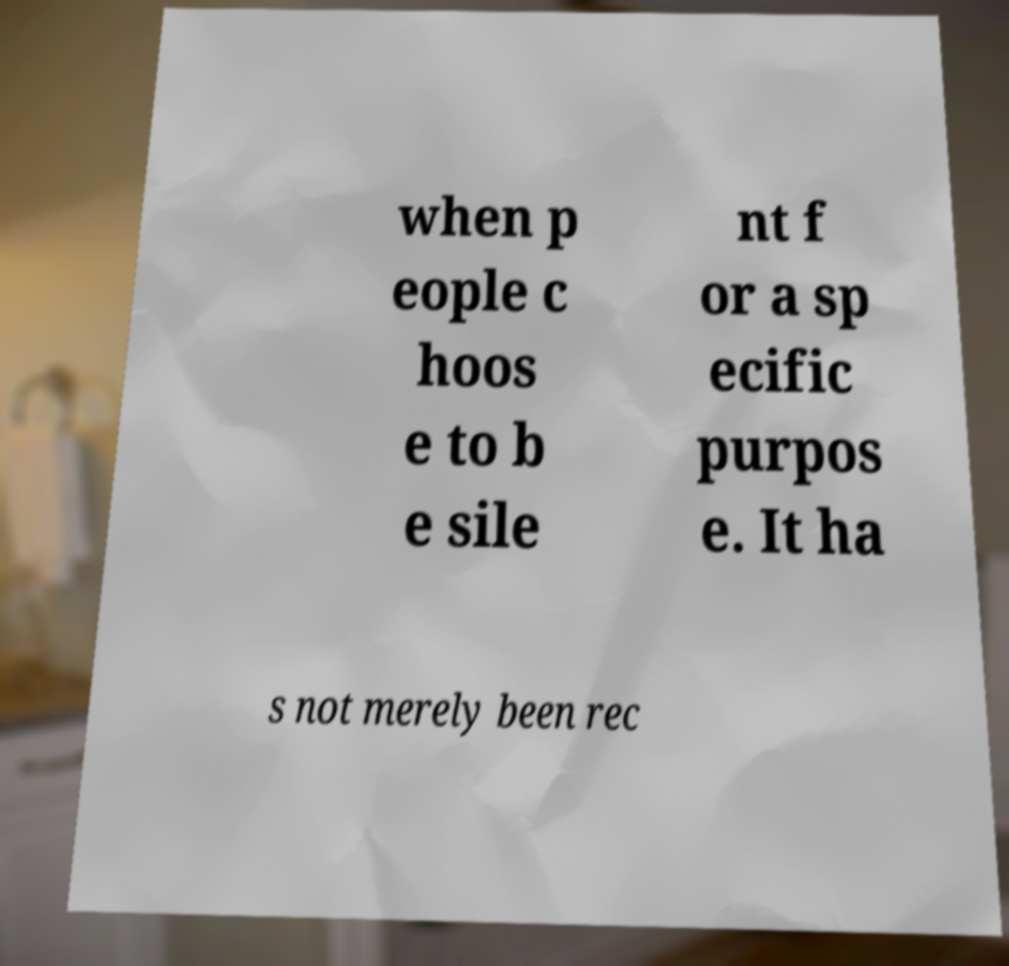There's text embedded in this image that I need extracted. Can you transcribe it verbatim? when p eople c hoos e to b e sile nt f or a sp ecific purpos e. It ha s not merely been rec 